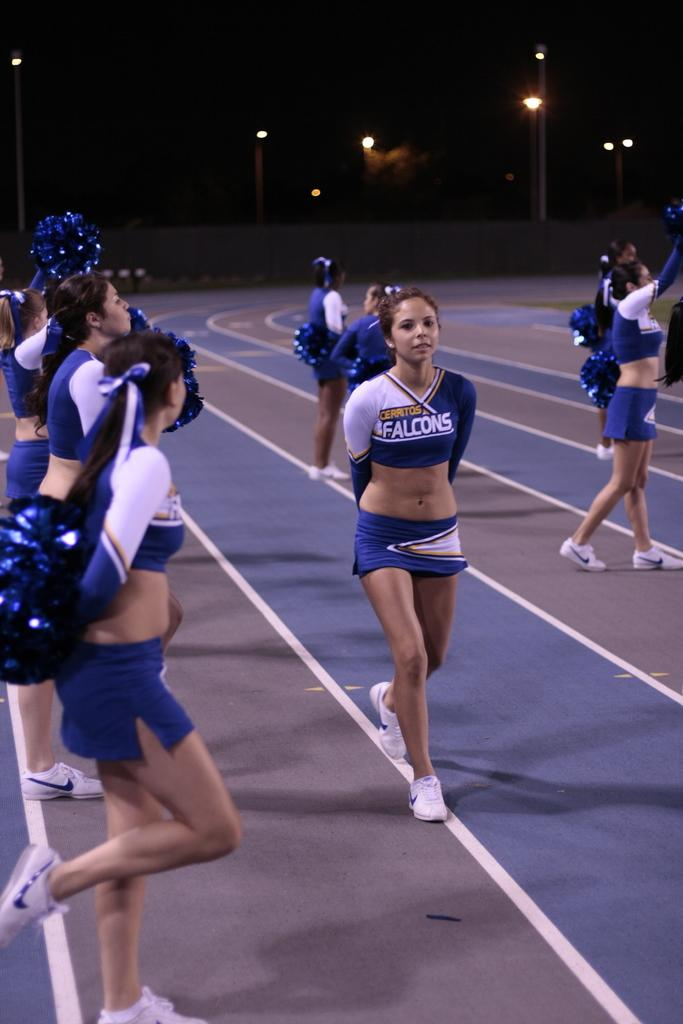<image>
Offer a succinct explanation of the picture presented. cheerleaders for the Falcons on a track do a cheer 